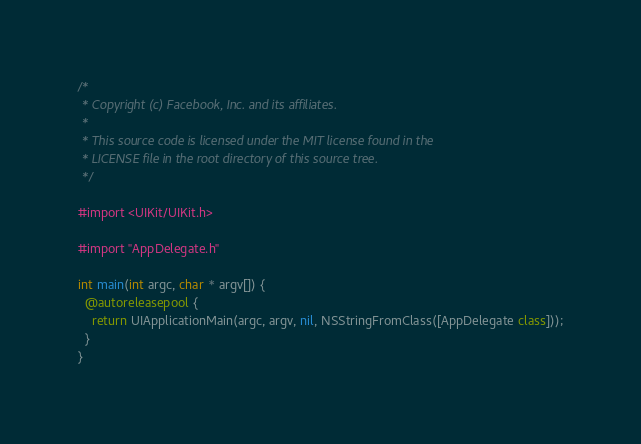Convert code to text. <code><loc_0><loc_0><loc_500><loc_500><_ObjectiveC_>/*
 * Copyright (c) Facebook, Inc. and its affiliates.
 *
 * This source code is licensed under the MIT license found in the
 * LICENSE file in the root directory of this source tree.
 */

#import <UIKit/UIKit.h>

#import "AppDelegate.h"

int main(int argc, char * argv[]) {
  @autoreleasepool {
    return UIApplicationMain(argc, argv, nil, NSStringFromClass([AppDelegate class]));
  }
}
</code> 